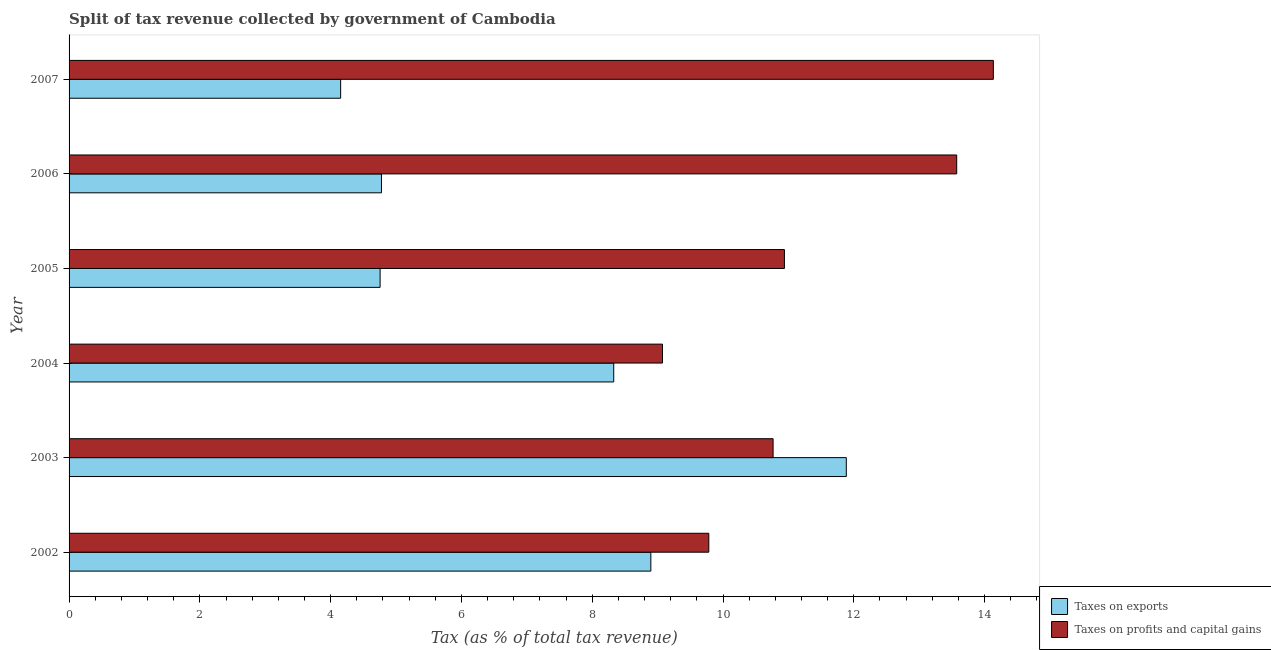How many groups of bars are there?
Make the answer very short. 6. Are the number of bars on each tick of the Y-axis equal?
Your response must be concise. Yes. How many bars are there on the 5th tick from the top?
Keep it short and to the point. 2. In how many cases, is the number of bars for a given year not equal to the number of legend labels?
Offer a very short reply. 0. What is the percentage of revenue obtained from taxes on exports in 2007?
Give a very brief answer. 4.15. Across all years, what is the maximum percentage of revenue obtained from taxes on exports?
Give a very brief answer. 11.89. Across all years, what is the minimum percentage of revenue obtained from taxes on exports?
Your response must be concise. 4.15. What is the total percentage of revenue obtained from taxes on exports in the graph?
Your answer should be compact. 42.8. What is the difference between the percentage of revenue obtained from taxes on profits and capital gains in 2002 and that in 2007?
Provide a short and direct response. -4.35. What is the difference between the percentage of revenue obtained from taxes on exports in 2004 and the percentage of revenue obtained from taxes on profits and capital gains in 2005?
Provide a succinct answer. -2.61. What is the average percentage of revenue obtained from taxes on profits and capital gains per year?
Offer a terse response. 11.38. In the year 2006, what is the difference between the percentage of revenue obtained from taxes on exports and percentage of revenue obtained from taxes on profits and capital gains?
Give a very brief answer. -8.8. In how many years, is the percentage of revenue obtained from taxes on profits and capital gains greater than 3.2 %?
Offer a very short reply. 6. What is the ratio of the percentage of revenue obtained from taxes on profits and capital gains in 2004 to that in 2006?
Keep it short and to the point. 0.67. Is the difference between the percentage of revenue obtained from taxes on profits and capital gains in 2005 and 2006 greater than the difference between the percentage of revenue obtained from taxes on exports in 2005 and 2006?
Offer a very short reply. No. What is the difference between the highest and the second highest percentage of revenue obtained from taxes on exports?
Your answer should be compact. 2.99. What is the difference between the highest and the lowest percentage of revenue obtained from taxes on profits and capital gains?
Your answer should be compact. 5.06. Is the sum of the percentage of revenue obtained from taxes on profits and capital gains in 2005 and 2006 greater than the maximum percentage of revenue obtained from taxes on exports across all years?
Provide a short and direct response. Yes. What does the 1st bar from the top in 2002 represents?
Ensure brevity in your answer.  Taxes on profits and capital gains. What does the 1st bar from the bottom in 2007 represents?
Give a very brief answer. Taxes on exports. Are all the bars in the graph horizontal?
Your answer should be compact. Yes. Are the values on the major ticks of X-axis written in scientific E-notation?
Give a very brief answer. No. Does the graph contain any zero values?
Offer a very short reply. No. How are the legend labels stacked?
Your answer should be compact. Vertical. What is the title of the graph?
Give a very brief answer. Split of tax revenue collected by government of Cambodia. Does "Male labor force" appear as one of the legend labels in the graph?
Ensure brevity in your answer.  No. What is the label or title of the X-axis?
Your answer should be very brief. Tax (as % of total tax revenue). What is the label or title of the Y-axis?
Provide a short and direct response. Year. What is the Tax (as % of total tax revenue) in Taxes on exports in 2002?
Make the answer very short. 8.9. What is the Tax (as % of total tax revenue) of Taxes on profits and capital gains in 2002?
Your answer should be very brief. 9.78. What is the Tax (as % of total tax revenue) of Taxes on exports in 2003?
Provide a succinct answer. 11.89. What is the Tax (as % of total tax revenue) in Taxes on profits and capital gains in 2003?
Keep it short and to the point. 10.77. What is the Tax (as % of total tax revenue) in Taxes on exports in 2004?
Provide a succinct answer. 8.33. What is the Tax (as % of total tax revenue) of Taxes on profits and capital gains in 2004?
Your answer should be very brief. 9.07. What is the Tax (as % of total tax revenue) in Taxes on exports in 2005?
Give a very brief answer. 4.76. What is the Tax (as % of total tax revenue) of Taxes on profits and capital gains in 2005?
Provide a succinct answer. 10.94. What is the Tax (as % of total tax revenue) of Taxes on exports in 2006?
Offer a very short reply. 4.78. What is the Tax (as % of total tax revenue) in Taxes on profits and capital gains in 2006?
Offer a terse response. 13.57. What is the Tax (as % of total tax revenue) of Taxes on exports in 2007?
Offer a terse response. 4.15. What is the Tax (as % of total tax revenue) of Taxes on profits and capital gains in 2007?
Your answer should be very brief. 14.13. Across all years, what is the maximum Tax (as % of total tax revenue) in Taxes on exports?
Your answer should be compact. 11.89. Across all years, what is the maximum Tax (as % of total tax revenue) in Taxes on profits and capital gains?
Ensure brevity in your answer.  14.13. Across all years, what is the minimum Tax (as % of total tax revenue) of Taxes on exports?
Provide a succinct answer. 4.15. Across all years, what is the minimum Tax (as % of total tax revenue) in Taxes on profits and capital gains?
Your answer should be very brief. 9.07. What is the total Tax (as % of total tax revenue) of Taxes on exports in the graph?
Offer a very short reply. 42.8. What is the total Tax (as % of total tax revenue) of Taxes on profits and capital gains in the graph?
Your answer should be very brief. 68.27. What is the difference between the Tax (as % of total tax revenue) in Taxes on exports in 2002 and that in 2003?
Give a very brief answer. -2.99. What is the difference between the Tax (as % of total tax revenue) of Taxes on profits and capital gains in 2002 and that in 2003?
Ensure brevity in your answer.  -0.98. What is the difference between the Tax (as % of total tax revenue) of Taxes on exports in 2002 and that in 2004?
Keep it short and to the point. 0.57. What is the difference between the Tax (as % of total tax revenue) of Taxes on profits and capital gains in 2002 and that in 2004?
Give a very brief answer. 0.71. What is the difference between the Tax (as % of total tax revenue) in Taxes on exports in 2002 and that in 2005?
Your answer should be compact. 4.14. What is the difference between the Tax (as % of total tax revenue) of Taxes on profits and capital gains in 2002 and that in 2005?
Offer a very short reply. -1.16. What is the difference between the Tax (as % of total tax revenue) in Taxes on exports in 2002 and that in 2006?
Your answer should be very brief. 4.12. What is the difference between the Tax (as % of total tax revenue) in Taxes on profits and capital gains in 2002 and that in 2006?
Provide a succinct answer. -3.79. What is the difference between the Tax (as % of total tax revenue) in Taxes on exports in 2002 and that in 2007?
Offer a very short reply. 4.74. What is the difference between the Tax (as % of total tax revenue) in Taxes on profits and capital gains in 2002 and that in 2007?
Your answer should be very brief. -4.35. What is the difference between the Tax (as % of total tax revenue) in Taxes on exports in 2003 and that in 2004?
Keep it short and to the point. 3.56. What is the difference between the Tax (as % of total tax revenue) in Taxes on profits and capital gains in 2003 and that in 2004?
Provide a short and direct response. 1.69. What is the difference between the Tax (as % of total tax revenue) of Taxes on exports in 2003 and that in 2005?
Ensure brevity in your answer.  7.13. What is the difference between the Tax (as % of total tax revenue) in Taxes on profits and capital gains in 2003 and that in 2005?
Offer a terse response. -0.17. What is the difference between the Tax (as % of total tax revenue) in Taxes on exports in 2003 and that in 2006?
Make the answer very short. 7.11. What is the difference between the Tax (as % of total tax revenue) of Taxes on profits and capital gains in 2003 and that in 2006?
Ensure brevity in your answer.  -2.81. What is the difference between the Tax (as % of total tax revenue) of Taxes on exports in 2003 and that in 2007?
Your answer should be very brief. 7.73. What is the difference between the Tax (as % of total tax revenue) in Taxes on profits and capital gains in 2003 and that in 2007?
Offer a very short reply. -3.37. What is the difference between the Tax (as % of total tax revenue) of Taxes on exports in 2004 and that in 2005?
Offer a terse response. 3.57. What is the difference between the Tax (as % of total tax revenue) in Taxes on profits and capital gains in 2004 and that in 2005?
Your answer should be compact. -1.86. What is the difference between the Tax (as % of total tax revenue) of Taxes on exports in 2004 and that in 2006?
Your answer should be compact. 3.55. What is the difference between the Tax (as % of total tax revenue) in Taxes on profits and capital gains in 2004 and that in 2006?
Give a very brief answer. -4.5. What is the difference between the Tax (as % of total tax revenue) of Taxes on exports in 2004 and that in 2007?
Provide a short and direct response. 4.18. What is the difference between the Tax (as % of total tax revenue) of Taxes on profits and capital gains in 2004 and that in 2007?
Your response must be concise. -5.06. What is the difference between the Tax (as % of total tax revenue) in Taxes on exports in 2005 and that in 2006?
Ensure brevity in your answer.  -0.02. What is the difference between the Tax (as % of total tax revenue) in Taxes on profits and capital gains in 2005 and that in 2006?
Offer a very short reply. -2.63. What is the difference between the Tax (as % of total tax revenue) in Taxes on exports in 2005 and that in 2007?
Make the answer very short. 0.6. What is the difference between the Tax (as % of total tax revenue) of Taxes on profits and capital gains in 2005 and that in 2007?
Offer a terse response. -3.19. What is the difference between the Tax (as % of total tax revenue) of Taxes on exports in 2006 and that in 2007?
Your answer should be compact. 0.62. What is the difference between the Tax (as % of total tax revenue) in Taxes on profits and capital gains in 2006 and that in 2007?
Provide a succinct answer. -0.56. What is the difference between the Tax (as % of total tax revenue) of Taxes on exports in 2002 and the Tax (as % of total tax revenue) of Taxes on profits and capital gains in 2003?
Provide a succinct answer. -1.87. What is the difference between the Tax (as % of total tax revenue) of Taxes on exports in 2002 and the Tax (as % of total tax revenue) of Taxes on profits and capital gains in 2004?
Your answer should be very brief. -0.18. What is the difference between the Tax (as % of total tax revenue) in Taxes on exports in 2002 and the Tax (as % of total tax revenue) in Taxes on profits and capital gains in 2005?
Your response must be concise. -2.04. What is the difference between the Tax (as % of total tax revenue) in Taxes on exports in 2002 and the Tax (as % of total tax revenue) in Taxes on profits and capital gains in 2006?
Provide a short and direct response. -4.68. What is the difference between the Tax (as % of total tax revenue) in Taxes on exports in 2002 and the Tax (as % of total tax revenue) in Taxes on profits and capital gains in 2007?
Keep it short and to the point. -5.24. What is the difference between the Tax (as % of total tax revenue) in Taxes on exports in 2003 and the Tax (as % of total tax revenue) in Taxes on profits and capital gains in 2004?
Your response must be concise. 2.81. What is the difference between the Tax (as % of total tax revenue) in Taxes on exports in 2003 and the Tax (as % of total tax revenue) in Taxes on profits and capital gains in 2005?
Your answer should be very brief. 0.95. What is the difference between the Tax (as % of total tax revenue) of Taxes on exports in 2003 and the Tax (as % of total tax revenue) of Taxes on profits and capital gains in 2006?
Make the answer very short. -1.69. What is the difference between the Tax (as % of total tax revenue) of Taxes on exports in 2003 and the Tax (as % of total tax revenue) of Taxes on profits and capital gains in 2007?
Give a very brief answer. -2.25. What is the difference between the Tax (as % of total tax revenue) of Taxes on exports in 2004 and the Tax (as % of total tax revenue) of Taxes on profits and capital gains in 2005?
Your answer should be compact. -2.61. What is the difference between the Tax (as % of total tax revenue) of Taxes on exports in 2004 and the Tax (as % of total tax revenue) of Taxes on profits and capital gains in 2006?
Your response must be concise. -5.24. What is the difference between the Tax (as % of total tax revenue) of Taxes on exports in 2004 and the Tax (as % of total tax revenue) of Taxes on profits and capital gains in 2007?
Make the answer very short. -5.81. What is the difference between the Tax (as % of total tax revenue) of Taxes on exports in 2005 and the Tax (as % of total tax revenue) of Taxes on profits and capital gains in 2006?
Your answer should be compact. -8.82. What is the difference between the Tax (as % of total tax revenue) of Taxes on exports in 2005 and the Tax (as % of total tax revenue) of Taxes on profits and capital gains in 2007?
Offer a terse response. -9.38. What is the difference between the Tax (as % of total tax revenue) of Taxes on exports in 2006 and the Tax (as % of total tax revenue) of Taxes on profits and capital gains in 2007?
Offer a very short reply. -9.36. What is the average Tax (as % of total tax revenue) in Taxes on exports per year?
Give a very brief answer. 7.13. What is the average Tax (as % of total tax revenue) of Taxes on profits and capital gains per year?
Your answer should be very brief. 11.38. In the year 2002, what is the difference between the Tax (as % of total tax revenue) in Taxes on exports and Tax (as % of total tax revenue) in Taxes on profits and capital gains?
Provide a short and direct response. -0.89. In the year 2003, what is the difference between the Tax (as % of total tax revenue) of Taxes on exports and Tax (as % of total tax revenue) of Taxes on profits and capital gains?
Give a very brief answer. 1.12. In the year 2004, what is the difference between the Tax (as % of total tax revenue) of Taxes on exports and Tax (as % of total tax revenue) of Taxes on profits and capital gains?
Ensure brevity in your answer.  -0.75. In the year 2005, what is the difference between the Tax (as % of total tax revenue) of Taxes on exports and Tax (as % of total tax revenue) of Taxes on profits and capital gains?
Ensure brevity in your answer.  -6.18. In the year 2006, what is the difference between the Tax (as % of total tax revenue) of Taxes on exports and Tax (as % of total tax revenue) of Taxes on profits and capital gains?
Ensure brevity in your answer.  -8.8. In the year 2007, what is the difference between the Tax (as % of total tax revenue) in Taxes on exports and Tax (as % of total tax revenue) in Taxes on profits and capital gains?
Your answer should be compact. -9.98. What is the ratio of the Tax (as % of total tax revenue) of Taxes on exports in 2002 to that in 2003?
Your answer should be compact. 0.75. What is the ratio of the Tax (as % of total tax revenue) in Taxes on profits and capital gains in 2002 to that in 2003?
Offer a very short reply. 0.91. What is the ratio of the Tax (as % of total tax revenue) in Taxes on exports in 2002 to that in 2004?
Your answer should be compact. 1.07. What is the ratio of the Tax (as % of total tax revenue) of Taxes on profits and capital gains in 2002 to that in 2004?
Give a very brief answer. 1.08. What is the ratio of the Tax (as % of total tax revenue) in Taxes on exports in 2002 to that in 2005?
Provide a short and direct response. 1.87. What is the ratio of the Tax (as % of total tax revenue) of Taxes on profits and capital gains in 2002 to that in 2005?
Give a very brief answer. 0.89. What is the ratio of the Tax (as % of total tax revenue) of Taxes on exports in 2002 to that in 2006?
Ensure brevity in your answer.  1.86. What is the ratio of the Tax (as % of total tax revenue) in Taxes on profits and capital gains in 2002 to that in 2006?
Give a very brief answer. 0.72. What is the ratio of the Tax (as % of total tax revenue) of Taxes on exports in 2002 to that in 2007?
Provide a short and direct response. 2.14. What is the ratio of the Tax (as % of total tax revenue) of Taxes on profits and capital gains in 2002 to that in 2007?
Keep it short and to the point. 0.69. What is the ratio of the Tax (as % of total tax revenue) of Taxes on exports in 2003 to that in 2004?
Offer a very short reply. 1.43. What is the ratio of the Tax (as % of total tax revenue) of Taxes on profits and capital gains in 2003 to that in 2004?
Your answer should be very brief. 1.19. What is the ratio of the Tax (as % of total tax revenue) of Taxes on exports in 2003 to that in 2005?
Make the answer very short. 2.5. What is the ratio of the Tax (as % of total tax revenue) in Taxes on profits and capital gains in 2003 to that in 2005?
Your response must be concise. 0.98. What is the ratio of the Tax (as % of total tax revenue) in Taxes on exports in 2003 to that in 2006?
Make the answer very short. 2.49. What is the ratio of the Tax (as % of total tax revenue) in Taxes on profits and capital gains in 2003 to that in 2006?
Your response must be concise. 0.79. What is the ratio of the Tax (as % of total tax revenue) in Taxes on exports in 2003 to that in 2007?
Your response must be concise. 2.86. What is the ratio of the Tax (as % of total tax revenue) in Taxes on profits and capital gains in 2003 to that in 2007?
Make the answer very short. 0.76. What is the ratio of the Tax (as % of total tax revenue) of Taxes on exports in 2004 to that in 2005?
Offer a terse response. 1.75. What is the ratio of the Tax (as % of total tax revenue) of Taxes on profits and capital gains in 2004 to that in 2005?
Offer a terse response. 0.83. What is the ratio of the Tax (as % of total tax revenue) of Taxes on exports in 2004 to that in 2006?
Your answer should be compact. 1.74. What is the ratio of the Tax (as % of total tax revenue) in Taxes on profits and capital gains in 2004 to that in 2006?
Give a very brief answer. 0.67. What is the ratio of the Tax (as % of total tax revenue) of Taxes on exports in 2004 to that in 2007?
Make the answer very short. 2.01. What is the ratio of the Tax (as % of total tax revenue) in Taxes on profits and capital gains in 2004 to that in 2007?
Ensure brevity in your answer.  0.64. What is the ratio of the Tax (as % of total tax revenue) in Taxes on exports in 2005 to that in 2006?
Ensure brevity in your answer.  1. What is the ratio of the Tax (as % of total tax revenue) in Taxes on profits and capital gains in 2005 to that in 2006?
Keep it short and to the point. 0.81. What is the ratio of the Tax (as % of total tax revenue) in Taxes on exports in 2005 to that in 2007?
Ensure brevity in your answer.  1.15. What is the ratio of the Tax (as % of total tax revenue) of Taxes on profits and capital gains in 2005 to that in 2007?
Offer a very short reply. 0.77. What is the ratio of the Tax (as % of total tax revenue) in Taxes on exports in 2006 to that in 2007?
Your answer should be compact. 1.15. What is the ratio of the Tax (as % of total tax revenue) in Taxes on profits and capital gains in 2006 to that in 2007?
Your answer should be compact. 0.96. What is the difference between the highest and the second highest Tax (as % of total tax revenue) of Taxes on exports?
Make the answer very short. 2.99. What is the difference between the highest and the second highest Tax (as % of total tax revenue) in Taxes on profits and capital gains?
Offer a very short reply. 0.56. What is the difference between the highest and the lowest Tax (as % of total tax revenue) in Taxes on exports?
Your answer should be very brief. 7.73. What is the difference between the highest and the lowest Tax (as % of total tax revenue) in Taxes on profits and capital gains?
Offer a very short reply. 5.06. 